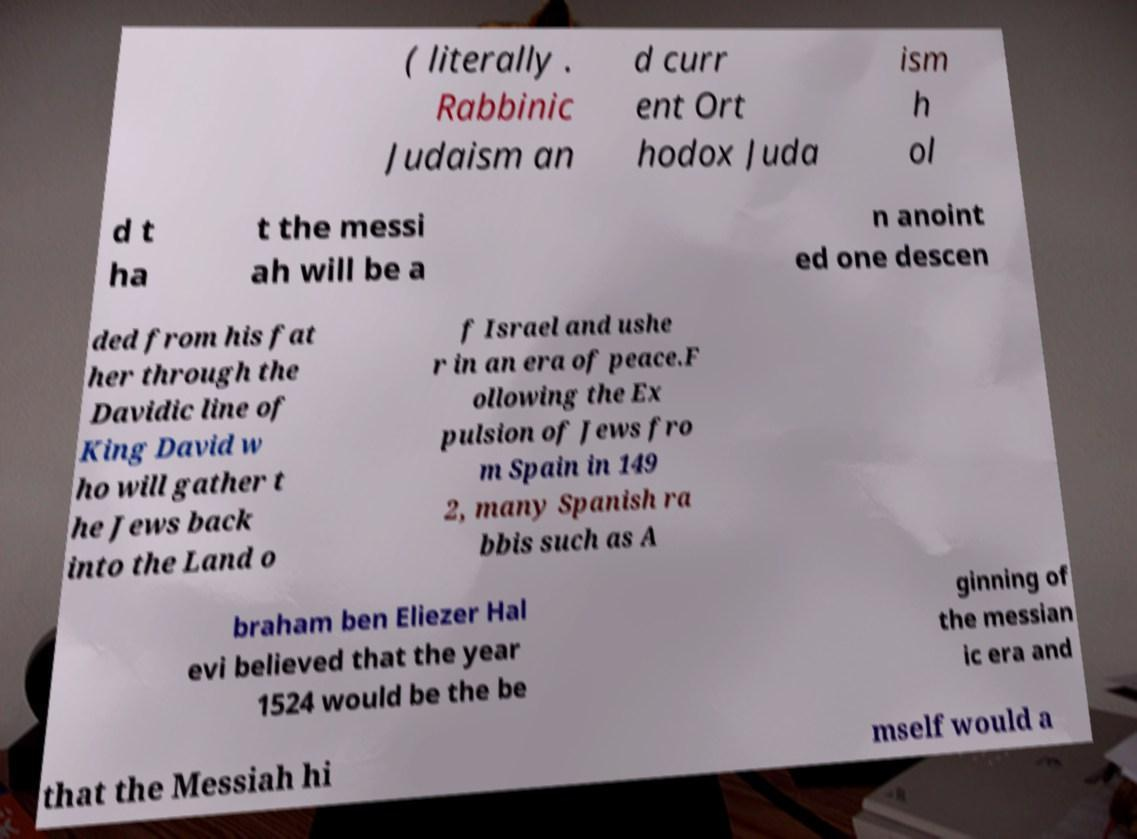Can you accurately transcribe the text from the provided image for me? ( literally . Rabbinic Judaism an d curr ent Ort hodox Juda ism h ol d t ha t the messi ah will be a n anoint ed one descen ded from his fat her through the Davidic line of King David w ho will gather t he Jews back into the Land o f Israel and ushe r in an era of peace.F ollowing the Ex pulsion of Jews fro m Spain in 149 2, many Spanish ra bbis such as A braham ben Eliezer Hal evi believed that the year 1524 would be the be ginning of the messian ic era and that the Messiah hi mself would a 